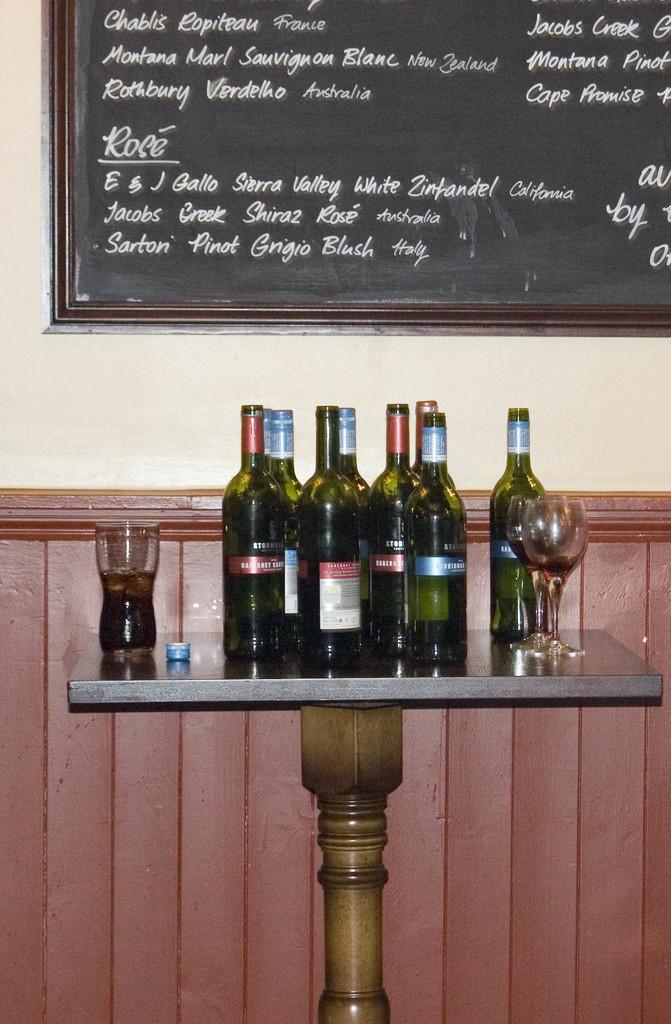What brand of white zinfandel is on the board?
Provide a short and direct response. E & j gallo sierra valley. What wine is from italy?
Your answer should be compact. Sarton pinot grigio blush. 